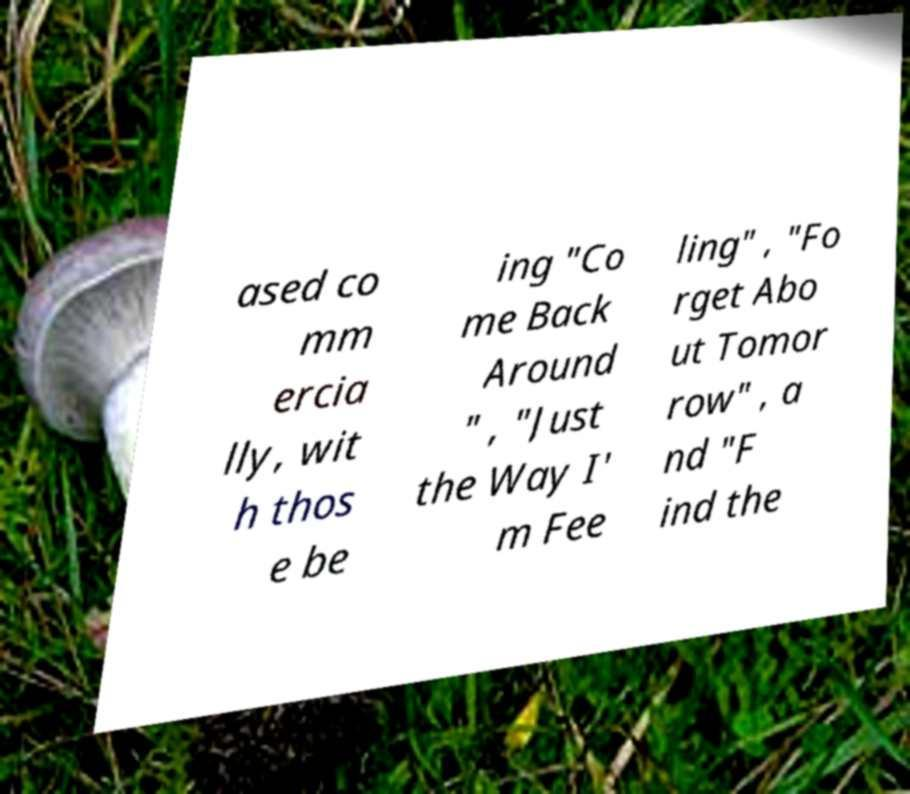Could you assist in decoding the text presented in this image and type it out clearly? ased co mm ercia lly, wit h thos e be ing "Co me Back Around " , "Just the Way I' m Fee ling" , "Fo rget Abo ut Tomor row" , a nd "F ind the 